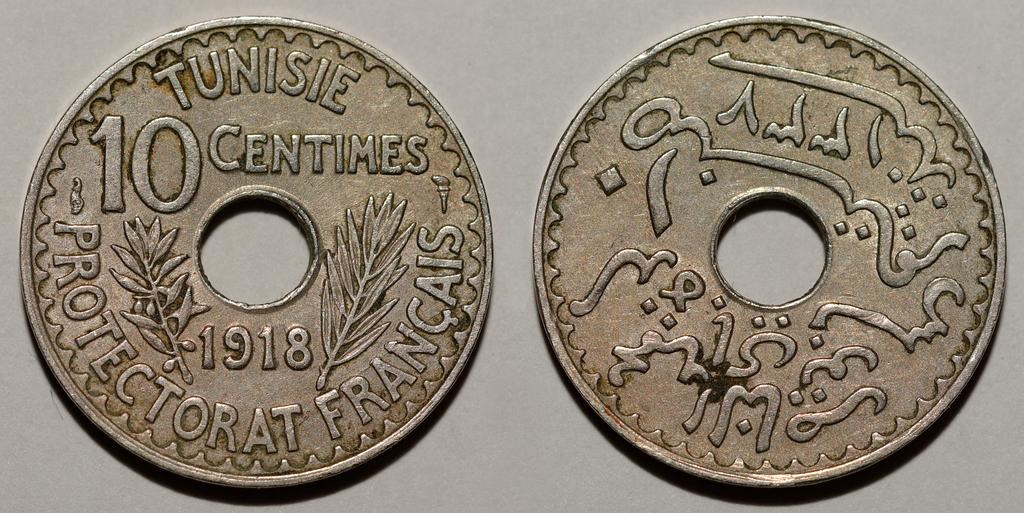<image>
Give a short and clear explanation of the subsequent image. a coin with a hole in the middle and has the words Tunisie Centimes on it 